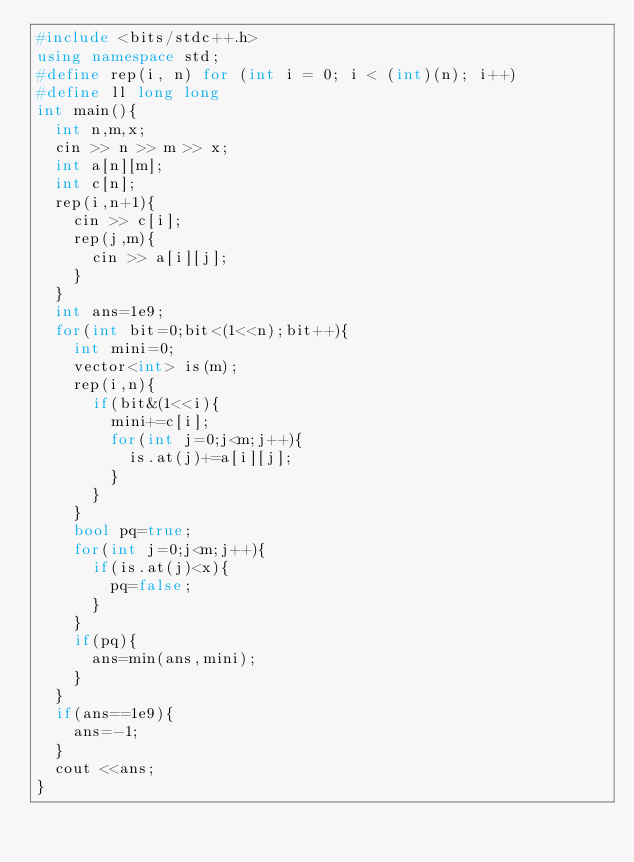Convert code to text. <code><loc_0><loc_0><loc_500><loc_500><_C++_>#include <bits/stdc++.h>
using namespace std;
#define rep(i, n) for (int i = 0; i < (int)(n); i++)
#define ll long long
int main(){
  int n,m,x;
  cin >> n >> m >> x;
  int a[n][m];
  int c[n];
  rep(i,n+1){
    cin >> c[i];
    rep(j,m){
      cin >> a[i][j];
    }
  }
  int ans=1e9;
  for(int bit=0;bit<(1<<n);bit++){
    int mini=0;
    vector<int> is(m);
    rep(i,n){
      if(bit&(1<<i){
        mini+=c[i];
        for(int j=0;j<m;j++){
          is.at(j)+=a[i][j];
        }
      }
    }
    bool pq=true;
    for(int j=0;j<m;j++){
      if(is.at(j)<x){
        pq=false;
      }
    }
    if(pq){
      ans=min(ans,mini);
    }
  }
  if(ans==1e9){
    ans=-1;
  }
  cout <<ans;
}
</code> 